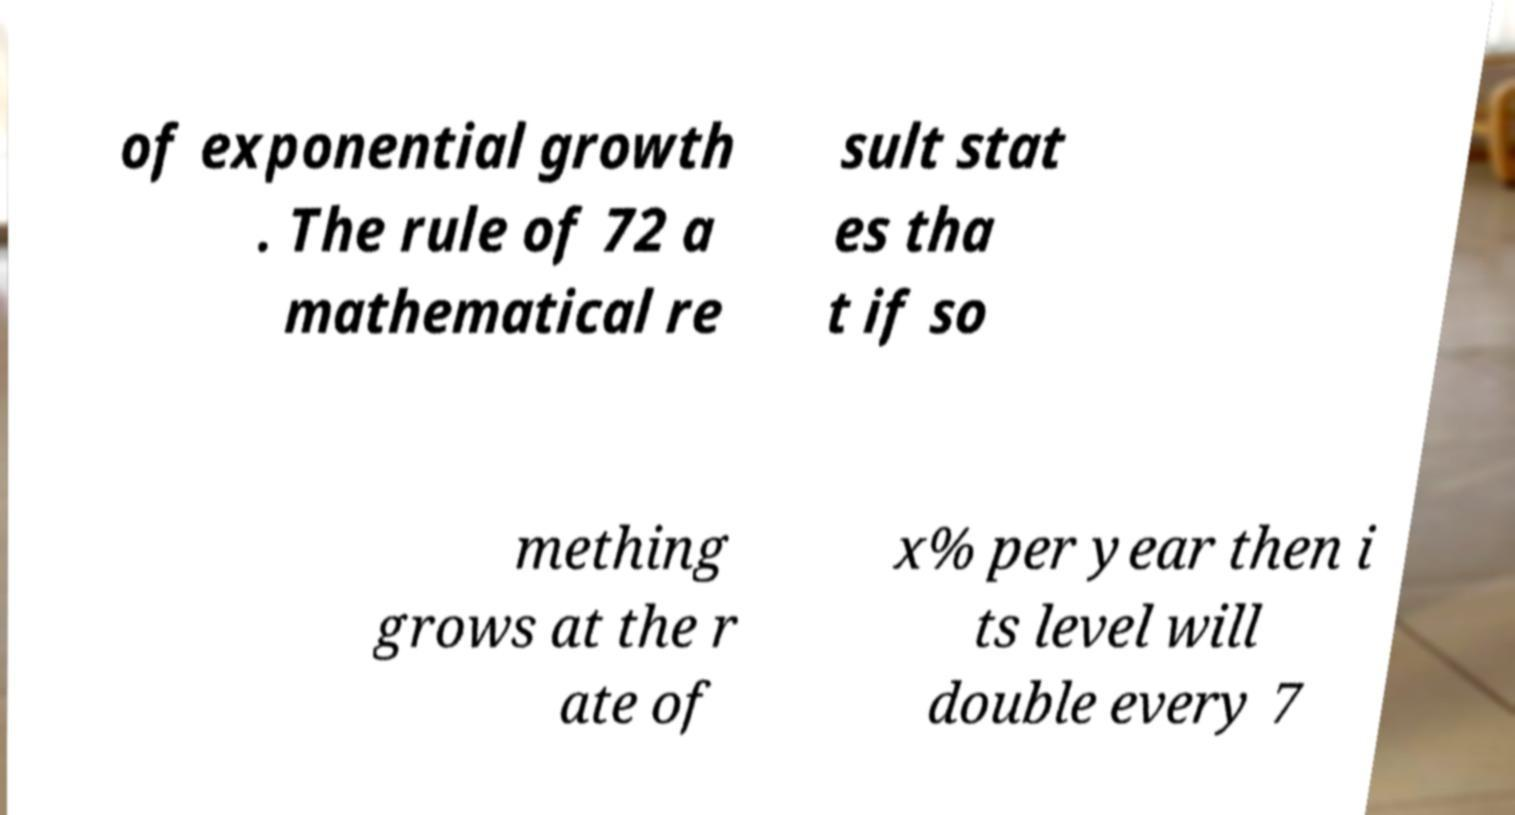Could you assist in decoding the text presented in this image and type it out clearly? of exponential growth . The rule of 72 a mathematical re sult stat es tha t if so mething grows at the r ate of x% per year then i ts level will double every 7 